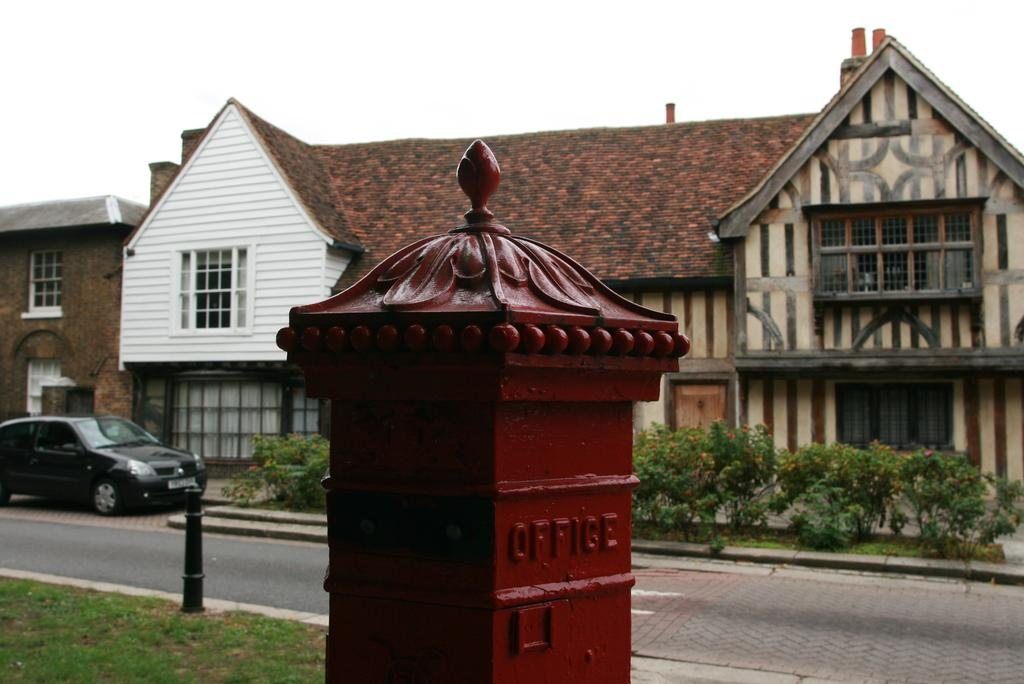What type of structure is in the image? There is a house in the image. What features can be seen on the house? The house has windows. What else is present in the image besides the house? There is a vehicle, a road, poles, grass, plants, and the sky visible in the image. What sound does the tendency make in the image? There is no mention of a "tendency" in the image, and therefore no sound can be attributed to it. 